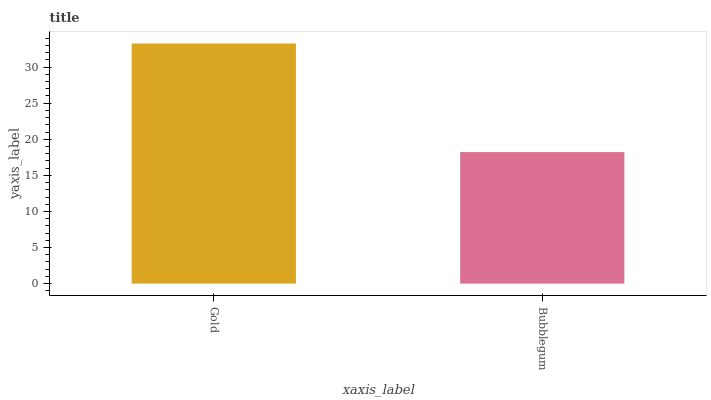Is Bubblegum the minimum?
Answer yes or no. Yes. Is Gold the maximum?
Answer yes or no. Yes. Is Bubblegum the maximum?
Answer yes or no. No. Is Gold greater than Bubblegum?
Answer yes or no. Yes. Is Bubblegum less than Gold?
Answer yes or no. Yes. Is Bubblegum greater than Gold?
Answer yes or no. No. Is Gold less than Bubblegum?
Answer yes or no. No. Is Gold the high median?
Answer yes or no. Yes. Is Bubblegum the low median?
Answer yes or no. Yes. Is Bubblegum the high median?
Answer yes or no. No. Is Gold the low median?
Answer yes or no. No. 